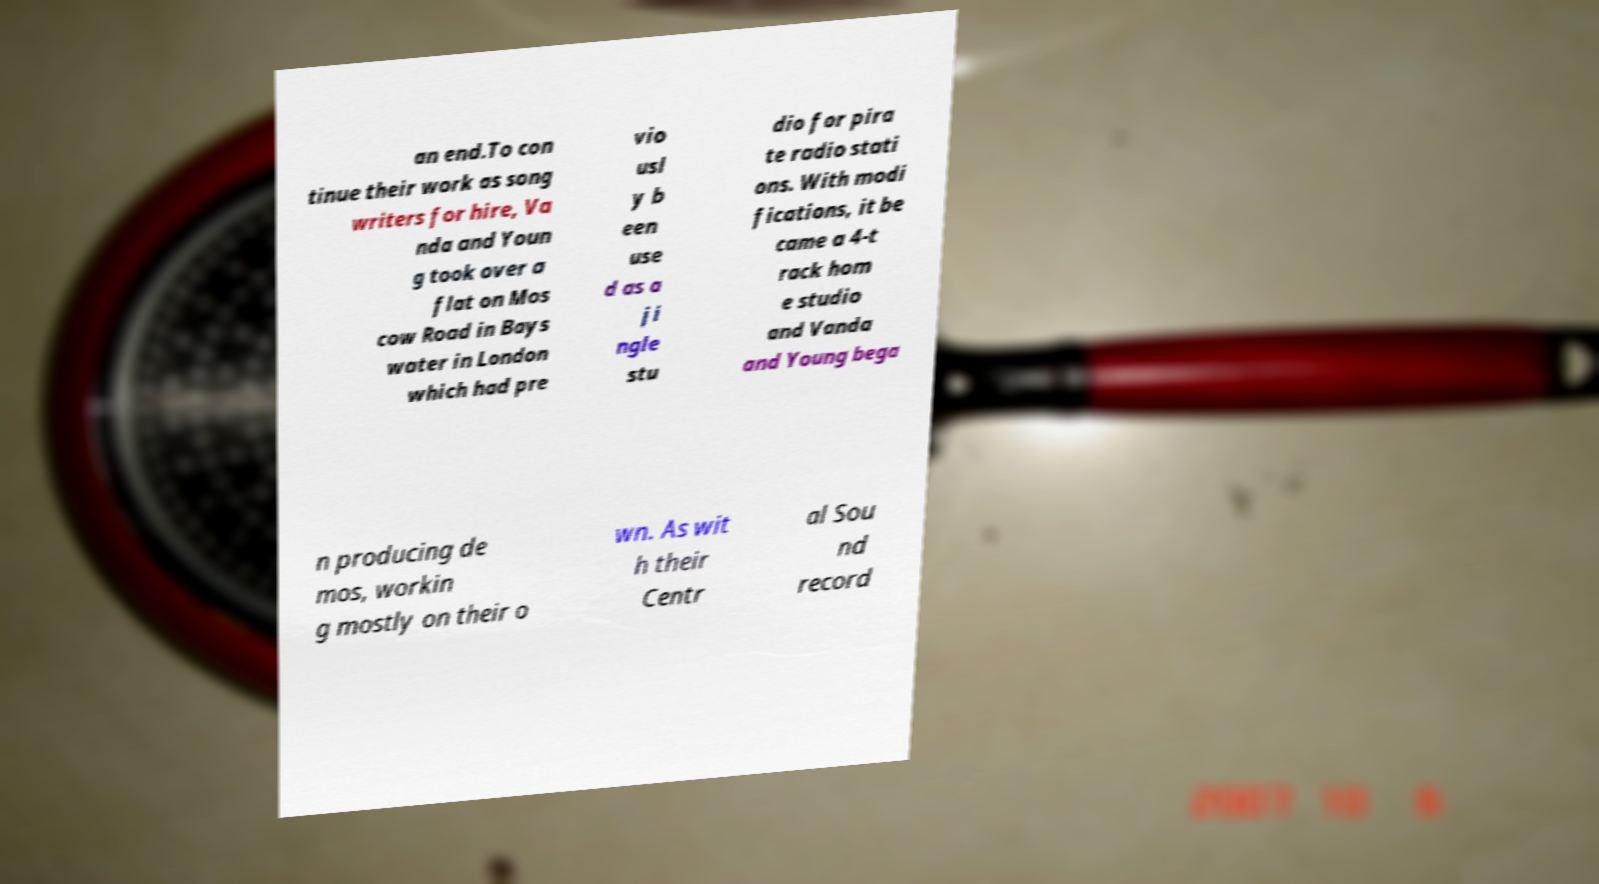I need the written content from this picture converted into text. Can you do that? an end.To con tinue their work as song writers for hire, Va nda and Youn g took over a flat on Mos cow Road in Bays water in London which had pre vio usl y b een use d as a ji ngle stu dio for pira te radio stati ons. With modi fications, it be came a 4-t rack hom e studio and Vanda and Young bega n producing de mos, workin g mostly on their o wn. As wit h their Centr al Sou nd record 